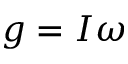<formula> <loc_0><loc_0><loc_500><loc_500>g = I \omega</formula> 